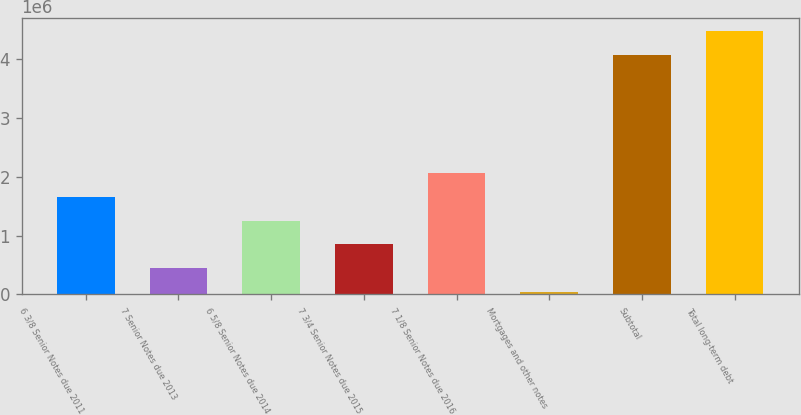Convert chart. <chart><loc_0><loc_0><loc_500><loc_500><bar_chart><fcel>6 3/8 Senior Notes due 2011<fcel>7 Senior Notes due 2013<fcel>6 5/8 Senior Notes due 2014<fcel>7 3/4 Senior Notes due 2015<fcel>7 1/8 Senior Notes due 2016<fcel>Mortgages and other notes<fcel>Subtotal<fcel>Total long-term debt<nl><fcel>1.65779e+06<fcel>449107<fcel>1.2549e+06<fcel>852003<fcel>2.06069e+06<fcel>46211<fcel>4.07517e+06<fcel>4.47806e+06<nl></chart> 